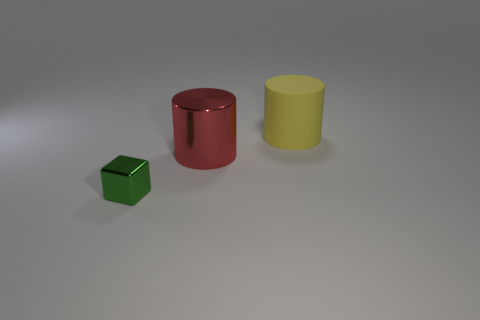Do the small green thing left of the red thing and the red thing have the same shape?
Keep it short and to the point. No. Are there more objects behind the yellow thing than big purple cubes?
Your response must be concise. No. What number of things have the same size as the matte cylinder?
Offer a terse response. 1. How many things are cylinders or big cylinders left of the big yellow matte cylinder?
Offer a terse response. 2. There is a object that is both in front of the large yellow rubber cylinder and on the right side of the small object; what is its color?
Make the answer very short. Red. Does the green block have the same size as the yellow object?
Ensure brevity in your answer.  No. The metallic object behind the small green metallic object is what color?
Give a very brief answer. Red. Is there a small object of the same color as the metallic cube?
Your answer should be compact. No. There is another cylinder that is the same size as the red metal cylinder; what is its color?
Offer a terse response. Yellow. Do the yellow matte object and the red object have the same shape?
Your answer should be very brief. Yes. 